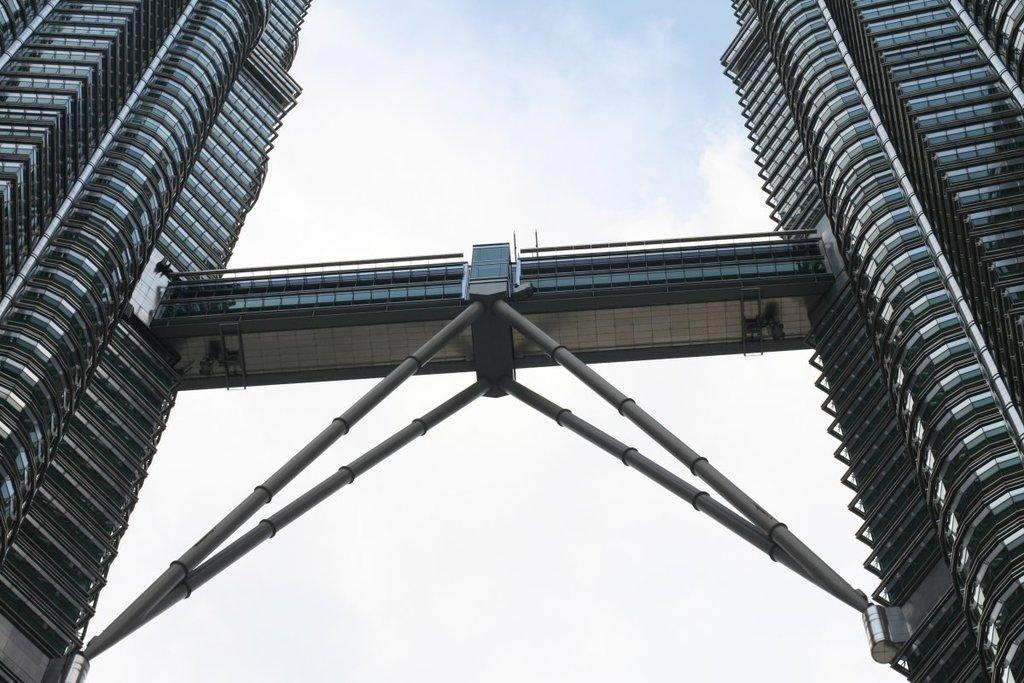What structures are present in the image? There are towers in the image. How are the towers connected? There is a bridge connecting the towers. What is the color and condition of the sky in the image? The sky is blue and cloudy. Can you see a ship sailing under the bridge in the image? There is no ship present in the image; it only features towers connected by a bridge. Is there a note attached to one of the towers in the image? There is no note visible in the image. 